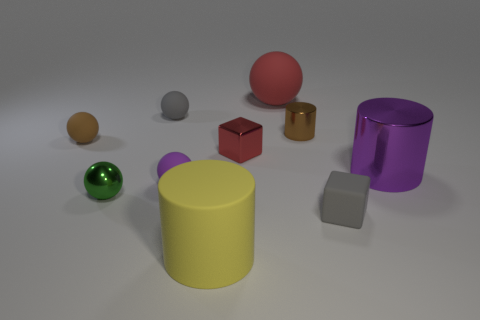What is the material of the purple thing to the right of the red metal thing?
Make the answer very short. Metal. Is there any other thing that has the same color as the big matte cylinder?
Your answer should be very brief. No. There is a yellow object that is the same material as the large sphere; what is its size?
Give a very brief answer. Large. How many big objects are either yellow cylinders or blue matte balls?
Your answer should be very brief. 1. There is a cylinder behind the tiny cube on the left side of the brown thing right of the small purple matte sphere; how big is it?
Your answer should be very brief. Small. How many metal things are the same size as the matte block?
Provide a short and direct response. 3. How many objects are either tiny brown balls or matte objects that are behind the large metallic object?
Give a very brief answer. 3. What is the shape of the large yellow object?
Provide a short and direct response. Cylinder. Do the big rubber ball and the metallic block have the same color?
Your answer should be compact. Yes. What is the color of the metallic cube that is the same size as the purple rubber object?
Your answer should be compact. Red. 